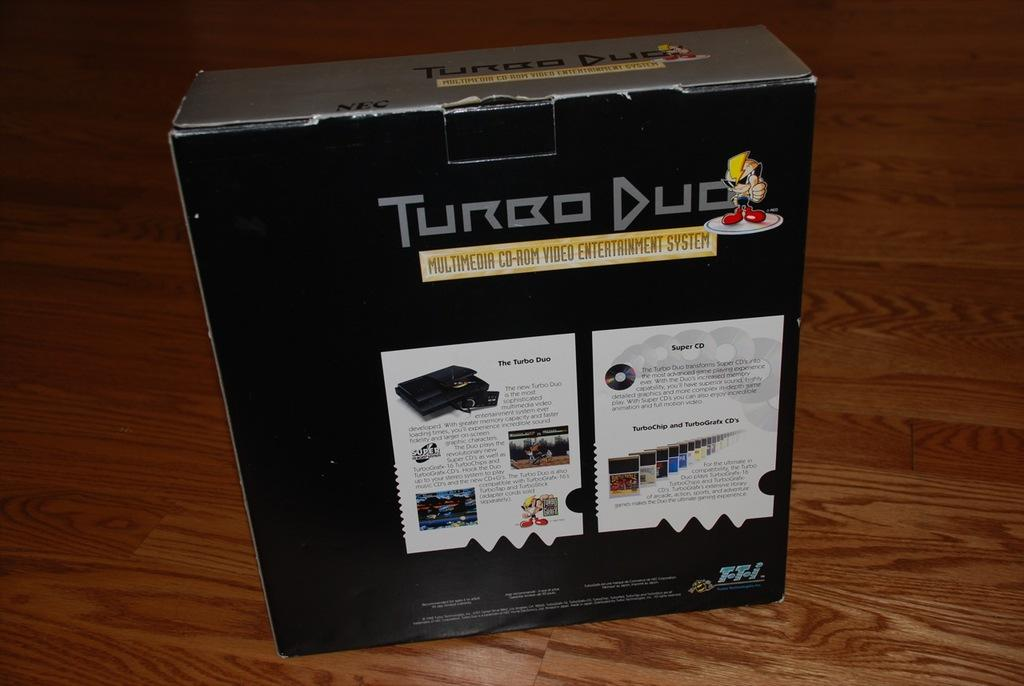<image>
Share a concise interpretation of the image provided. A black box of a multimedia cd-rom entertainment system 